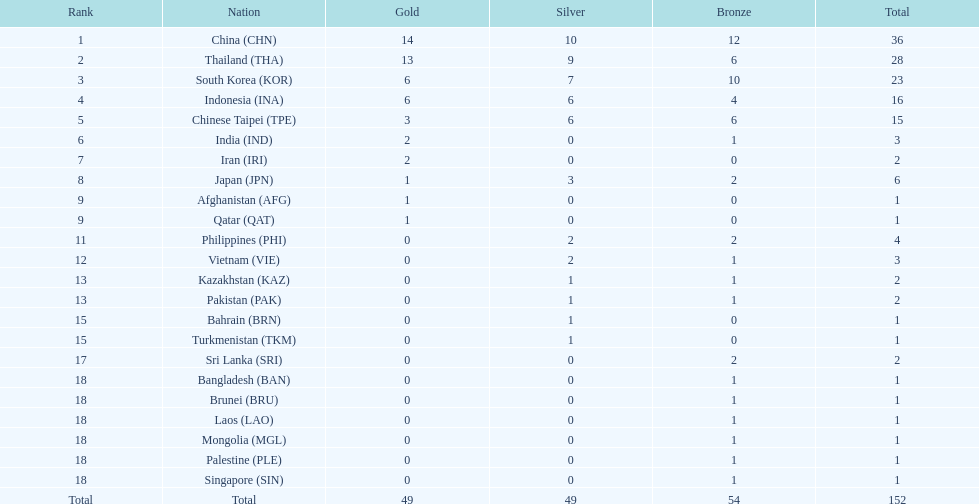What was the count of medals obtained by indonesia (ina)? 16. 